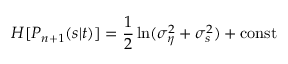<formula> <loc_0><loc_0><loc_500><loc_500>H [ P _ { n + 1 } ( s | t ) ] = \frac { 1 } { 2 } \ln ( \sigma _ { \eta } ^ { 2 } + \sigma _ { s } ^ { 2 } ) + c o n s t</formula> 